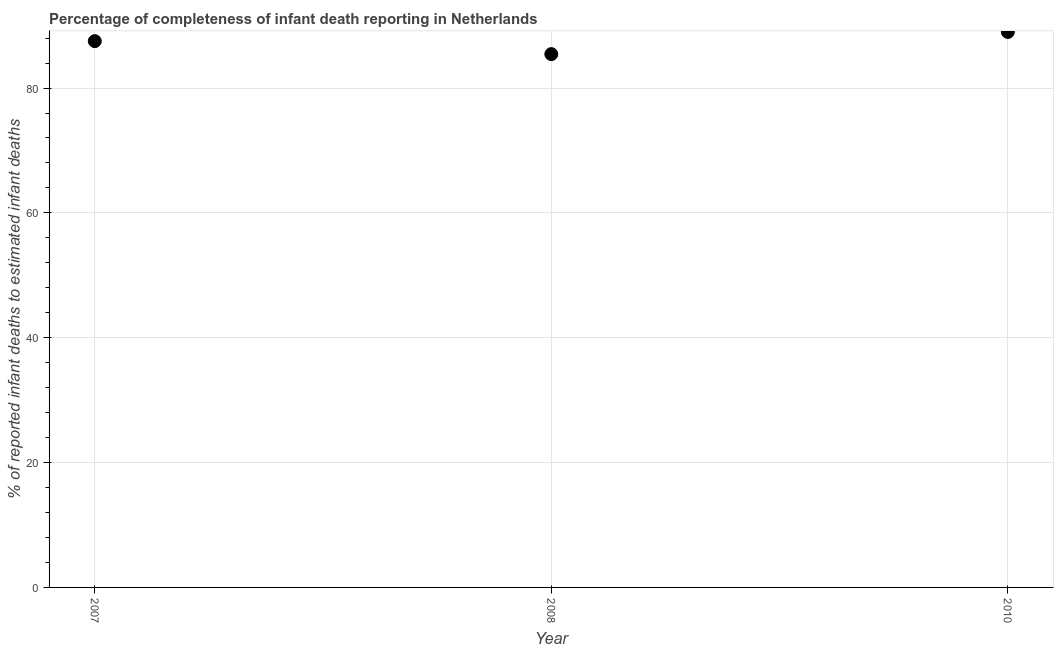What is the completeness of infant death reporting in 2008?
Your answer should be compact. 85.43. Across all years, what is the maximum completeness of infant death reporting?
Provide a succinct answer. 88.99. Across all years, what is the minimum completeness of infant death reporting?
Provide a succinct answer. 85.43. In which year was the completeness of infant death reporting minimum?
Ensure brevity in your answer.  2008. What is the sum of the completeness of infant death reporting?
Your response must be concise. 261.94. What is the difference between the completeness of infant death reporting in 2007 and 2010?
Offer a terse response. -1.47. What is the average completeness of infant death reporting per year?
Your answer should be very brief. 87.31. What is the median completeness of infant death reporting?
Make the answer very short. 87.51. Do a majority of the years between 2007 and 2008 (inclusive) have completeness of infant death reporting greater than 52 %?
Offer a very short reply. Yes. What is the ratio of the completeness of infant death reporting in 2008 to that in 2010?
Your answer should be very brief. 0.96. Is the difference between the completeness of infant death reporting in 2008 and 2010 greater than the difference between any two years?
Provide a succinct answer. Yes. What is the difference between the highest and the second highest completeness of infant death reporting?
Make the answer very short. 1.47. What is the difference between the highest and the lowest completeness of infant death reporting?
Make the answer very short. 3.55. Does the completeness of infant death reporting monotonically increase over the years?
Your answer should be very brief. No. How many dotlines are there?
Give a very brief answer. 1. How many years are there in the graph?
Offer a terse response. 3. What is the difference between two consecutive major ticks on the Y-axis?
Ensure brevity in your answer.  20. Are the values on the major ticks of Y-axis written in scientific E-notation?
Offer a terse response. No. Does the graph contain any zero values?
Make the answer very short. No. What is the title of the graph?
Give a very brief answer. Percentage of completeness of infant death reporting in Netherlands. What is the label or title of the Y-axis?
Give a very brief answer. % of reported infant deaths to estimated infant deaths. What is the % of reported infant deaths to estimated infant deaths in 2007?
Offer a terse response. 87.51. What is the % of reported infant deaths to estimated infant deaths in 2008?
Your answer should be compact. 85.43. What is the % of reported infant deaths to estimated infant deaths in 2010?
Keep it short and to the point. 88.99. What is the difference between the % of reported infant deaths to estimated infant deaths in 2007 and 2008?
Ensure brevity in your answer.  2.08. What is the difference between the % of reported infant deaths to estimated infant deaths in 2007 and 2010?
Make the answer very short. -1.47. What is the difference between the % of reported infant deaths to estimated infant deaths in 2008 and 2010?
Keep it short and to the point. -3.55. 